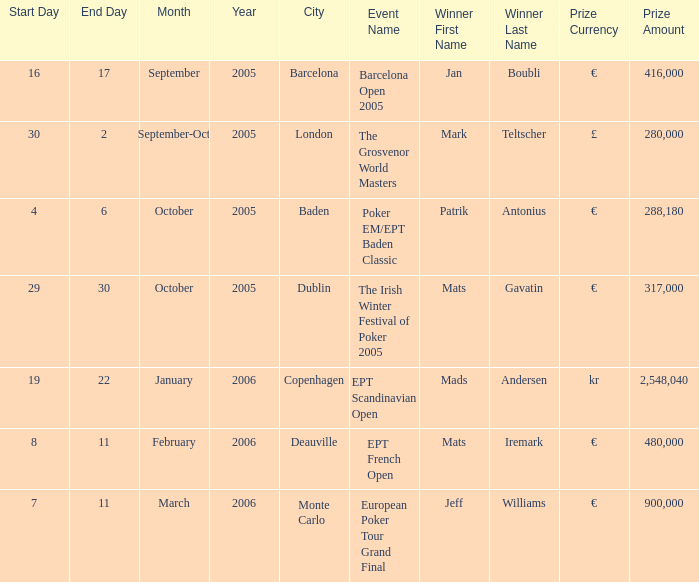When was the event in the City of Baden? 4–6 October 2005. 